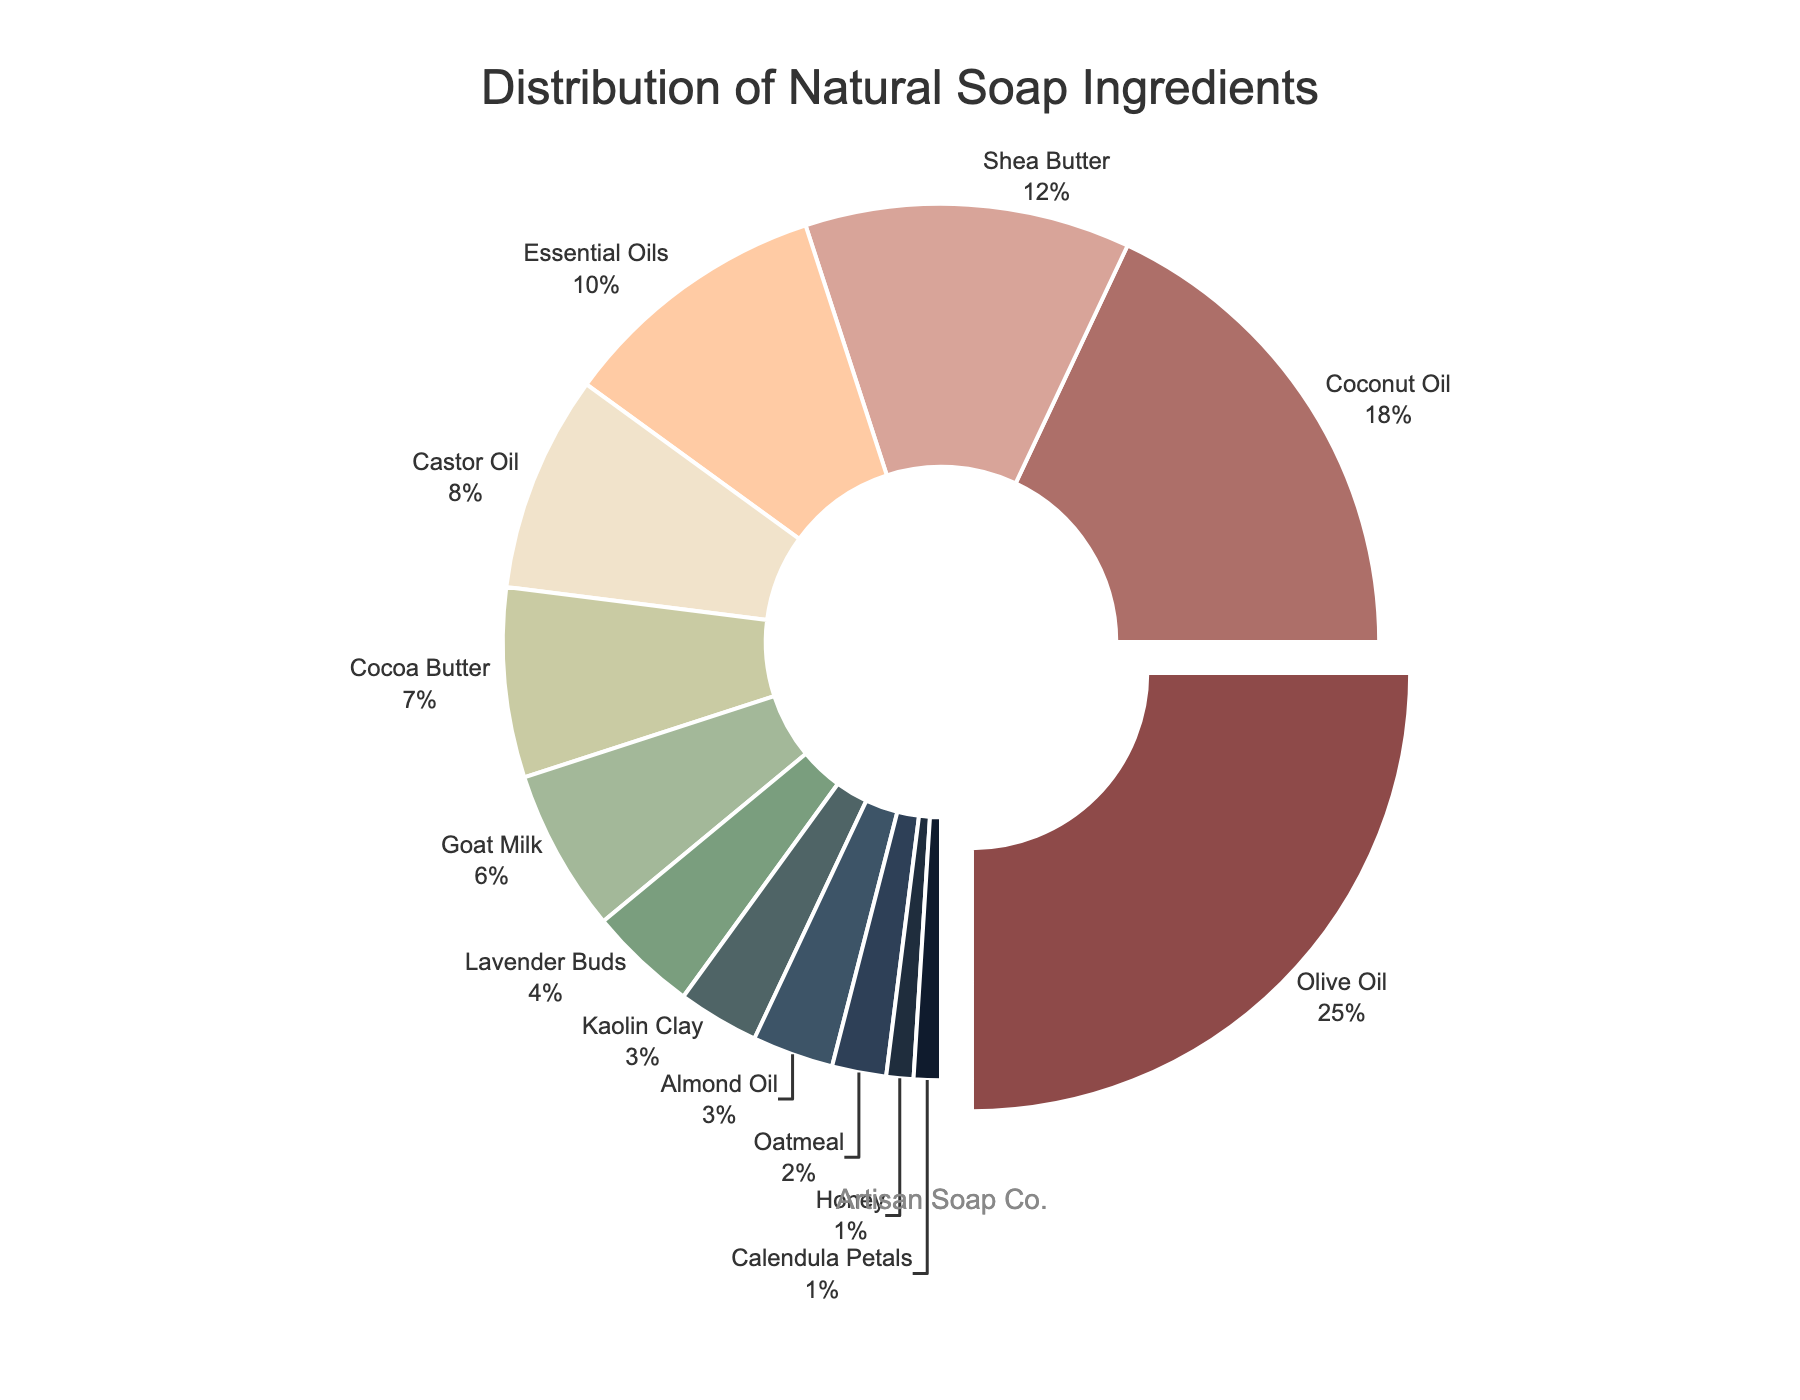What ingredient is the most popular? The ingredient occupying the largest segment of the pie chart represents the most popular ingredient, which is Olive Oil.
Answer: Olive Oil Which ingredient has the smallest percentage? Look for the smallest segment in the pie chart, which represents Honey and Calendula Petals at 1% each.
Answer: Honey and Calendula Petals What is the combined percentage of Coconut Oil, Shea Butter, and Essential Oils? Add the percentages of Coconut Oil (18%), Shea Butter (12%), and Essential Oils (10%). The total is 18 + 12 + 10 = 40.
Answer: 40% Is Olive Oil more popular than Coconut Oil and Shea Butter combined? Add the percentages of Coconut Oil (18%) and Shea Butter (12%), which gives 30%. Compare this to Olive Oil's 25%. 25% is less than 30%.
Answer: No Which ingredient has a higher percentage: Castor Oil or Cocoa Butter? Compare the percentages of Castor Oil (8%) and Cocoa Butter (7%), and note that 8% is greater than 7%.
Answer: Castor Oil What is the total percentage of ingredients that make up less than 5% each? Add the percentages of Lavender Buds (4%), Kaolin Clay (3%), Almond Oil (3%), Oatmeal (2%), Honey (1%), and Calendula Petals (1%). The sum is 4 + 3 + 3 + 2 + 1 + 1 = 14.
Answer: 14% If you combine the percentages of Goat Milk and Lavender Buds, would they together be more popular than Cocoa Butter? Goat Milk is 6% and Lavender Buds is 4%, summing them gives 6 + 4 = 10%. Compare this to Cocoa Butter's 7%. 10% is greater than 7%.
Answer: Yes What colors represent the two ingredients with the smallest percentages? The smallest percentages are Honey and Calendula Petals, which should be represented by the same two colors in the pie chart legend.
Answer: Honey: dark purple, Calendula Petals: very dark blue Which is higher: the sum of Olive Oil and Essential Oils or the sum of Castor Oil and Cocoa Butter? Olive Oil is 25% and Essential Oils are 10%, so their sum is 35%. Castor Oil is 8% and Cocoa Butter is 7%, so their sum is 15%. 35% is greater than 15%.
Answer: Olive Oil and Essential Oils 